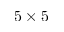Convert formula to latex. <formula><loc_0><loc_0><loc_500><loc_500>5 \times 5</formula> 